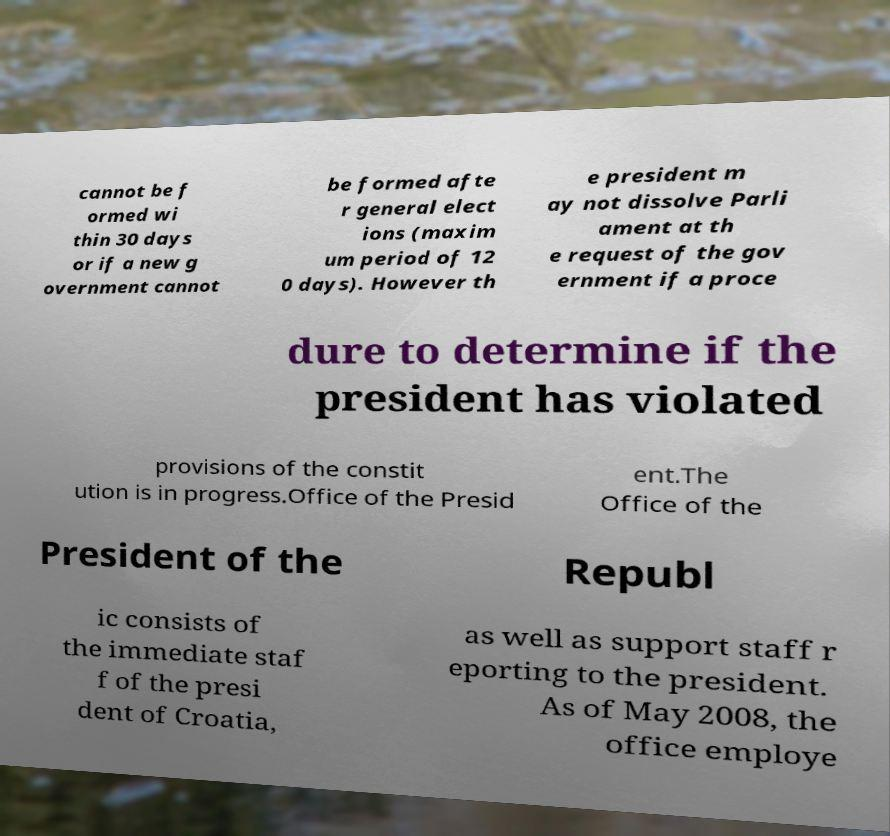Can you read and provide the text displayed in the image?This photo seems to have some interesting text. Can you extract and type it out for me? cannot be f ormed wi thin 30 days or if a new g overnment cannot be formed afte r general elect ions (maxim um period of 12 0 days). However th e president m ay not dissolve Parli ament at th e request of the gov ernment if a proce dure to determine if the president has violated provisions of the constit ution is in progress.Office of the Presid ent.The Office of the President of the Republ ic consists of the immediate staf f of the presi dent of Croatia, as well as support staff r eporting to the president. As of May 2008, the office employe 